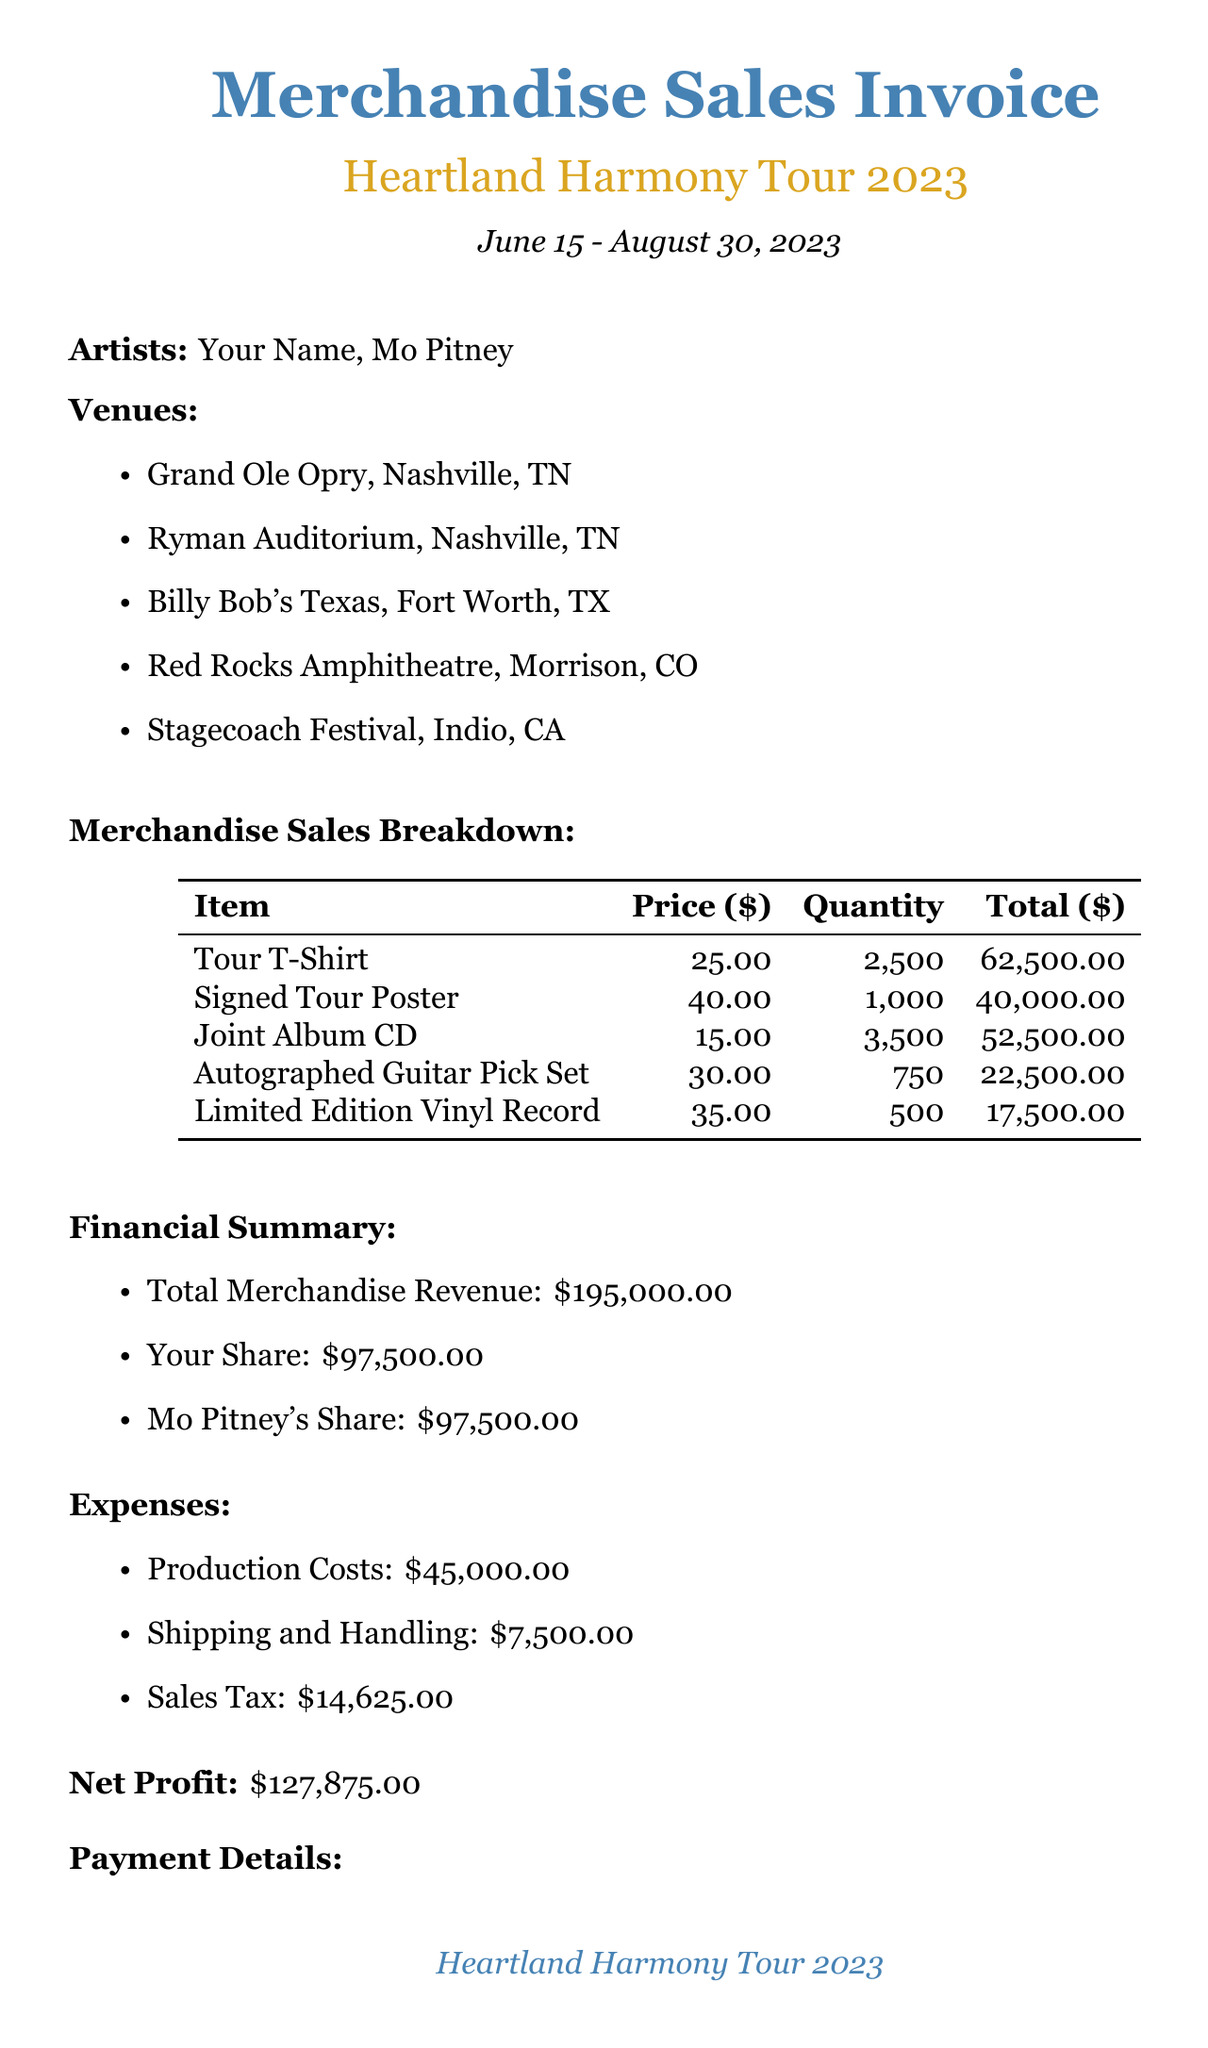What is the name of the tour? The tour name is listed at the top of the invoice as "Heartland Harmony Tour 2023."
Answer: Heartland Harmony Tour 2023 How many venues were listed for the tour? The venues are listed in bullet points, totaling five locations.
Answer: 5 What was the price of the Signed Tour Poster? The price is explicitly listed in the merchandise sales breakdown as $40.00.
Answer: $40.00 What is the total merchandise revenue? The total merchandise revenue is provided in the financial summary section as $195,000.00.
Answer: $195,000.00 Which item had the highest quantity sold? The Tour T-Shirt has the highest quantity sold at 2,500 units, as seen in the merchandise sales breakdown.
Answer: Tour T-Shirt What is your share of the revenue? Your share is stated in the financial summary as $97,500.00.
Answer: $97,500.00 What were the production costs? The production costs are detailed in the expenses section as $45,000.00.
Answer: $45,000.00 What was noted about merchandise sales exceeding projections? The additional notes indicate sales exceeded projections by 15%.
Answer: 15% What is the payment method for the share? The payment method is mentioned as "Direct Deposit" in the payment details section.
Answer: Direct Deposit 